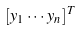<formula> <loc_0><loc_0><loc_500><loc_500>[ y _ { 1 } \cdot \cdot \cdot y _ { n } ] ^ { T }</formula> 